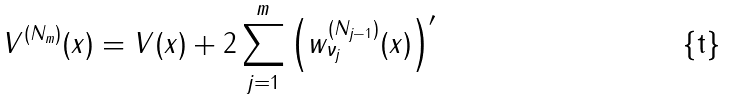<formula> <loc_0><loc_0><loc_500><loc_500>V ^ { ( N _ { m } ) } ( x ) = V ( x ) + 2 \sum _ { j = 1 } ^ { m } \left ( w _ { \nu _ { j } } ^ { ( N _ { j - 1 } ) } ( x ) \right ) ^ { \prime }</formula> 